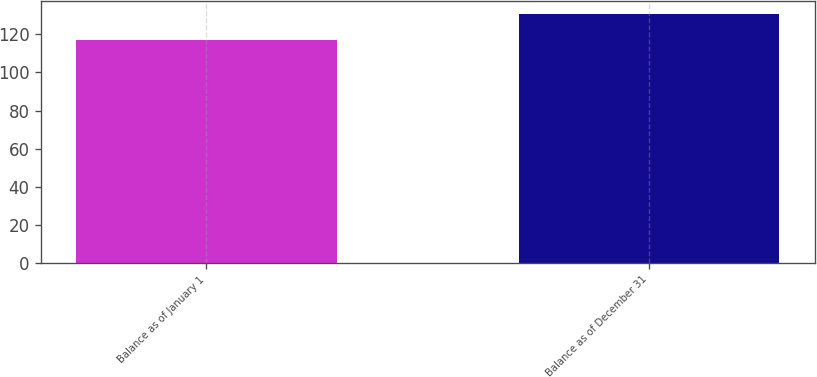Convert chart to OTSL. <chart><loc_0><loc_0><loc_500><loc_500><bar_chart><fcel>Balance as of January 1<fcel>Balance as of December 31<nl><fcel>117<fcel>131<nl></chart> 